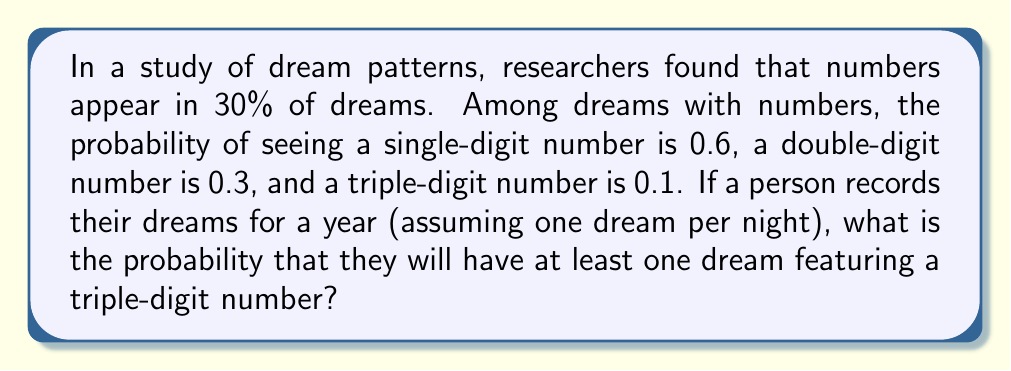Provide a solution to this math problem. Let's approach this step-by-step:

1) First, we need to calculate the probability of seeing a triple-digit number in any given dream:

   $P(\text{triple-digit}) = P(\text{number in dream}) \times P(\text{triple-digit | number in dream})$
   $= 0.30 \times 0.1 = 0.03$

2) Now, we need to find the probability of not seeing a triple-digit number in a dream:

   $P(\text{no triple-digit}) = 1 - P(\text{triple-digit}) = 1 - 0.03 = 0.97$

3) For a year of dreams (365 nights), the probability of not seeing a triple-digit number in any dream is:

   $P(\text{no triple-digit in a year}) = (0.97)^{365}$

4) Therefore, the probability of seeing at least one triple-digit number in a year of dreams is:

   $P(\text{at least one triple-digit in a year}) = 1 - P(\text{no triple-digit in a year})$
   $= 1 - (0.97)^{365}$

5) Calculating this:

   $1 - (0.97)^{365} \approx 1 - 0.000033 = 0.999967$
Answer: The probability of having at least one dream featuring a triple-digit number in a year is approximately 0.999967 or 99.9967%. 